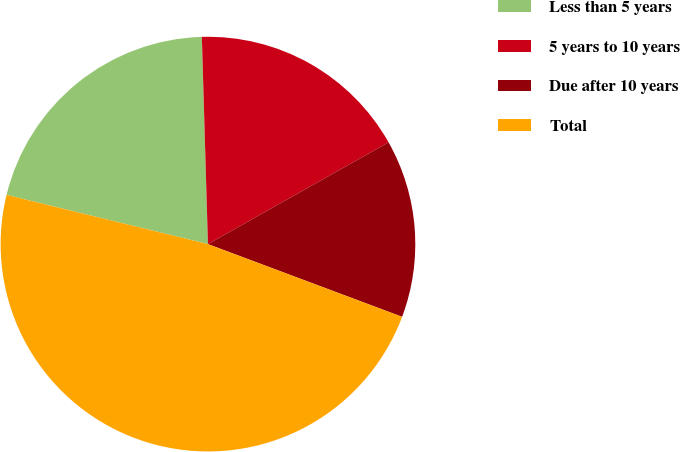Convert chart. <chart><loc_0><loc_0><loc_500><loc_500><pie_chart><fcel>Less than 5 years<fcel>5 years to 10 years<fcel>Due after 10 years<fcel>Total<nl><fcel>20.72%<fcel>17.3%<fcel>13.87%<fcel>48.11%<nl></chart> 